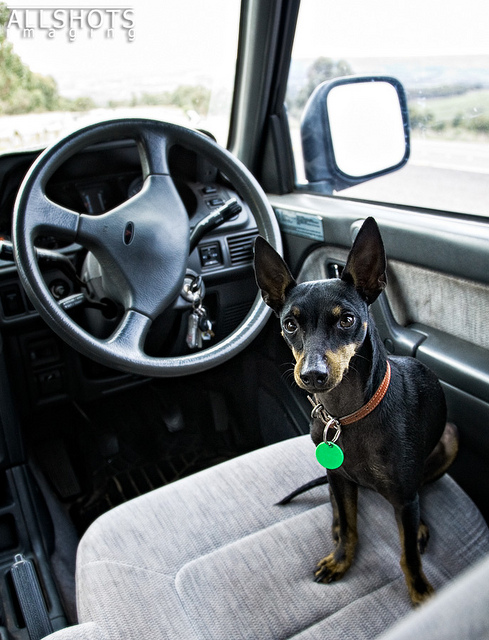<image>What is the dog thinking? It is unknown what the dog is thinking. What is the dog thinking? I don't know what the dog is thinking. It can be thinking about nothing, wanting to be fed, wanting to go for a walk, or something else. 